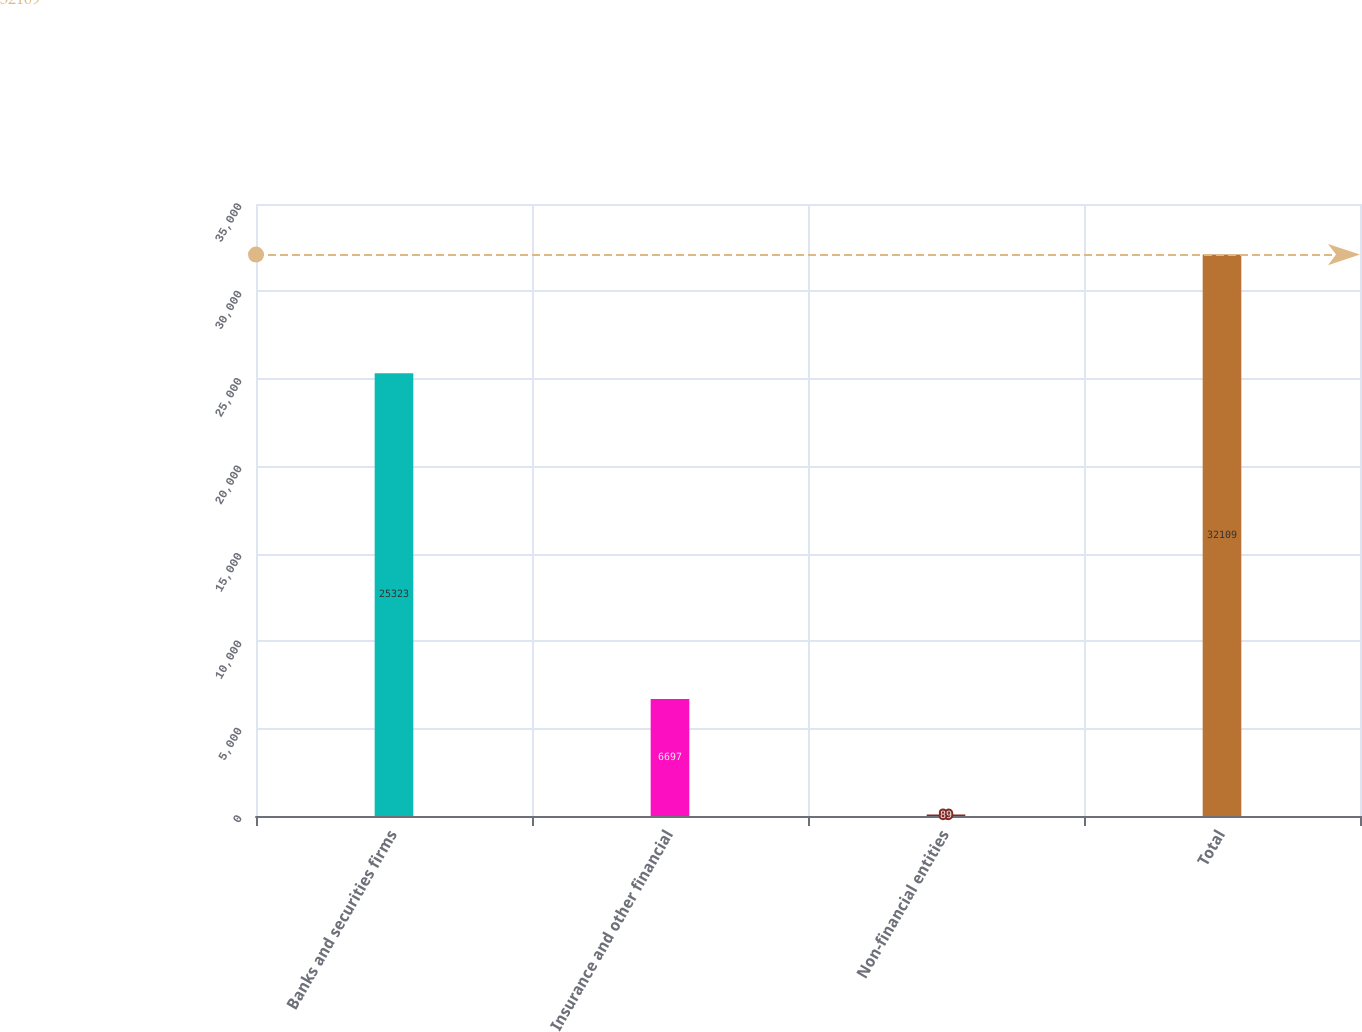<chart> <loc_0><loc_0><loc_500><loc_500><bar_chart><fcel>Banks and securities firms<fcel>Insurance and other financial<fcel>Non-financial entities<fcel>Total<nl><fcel>25323<fcel>6697<fcel>89<fcel>32109<nl></chart> 